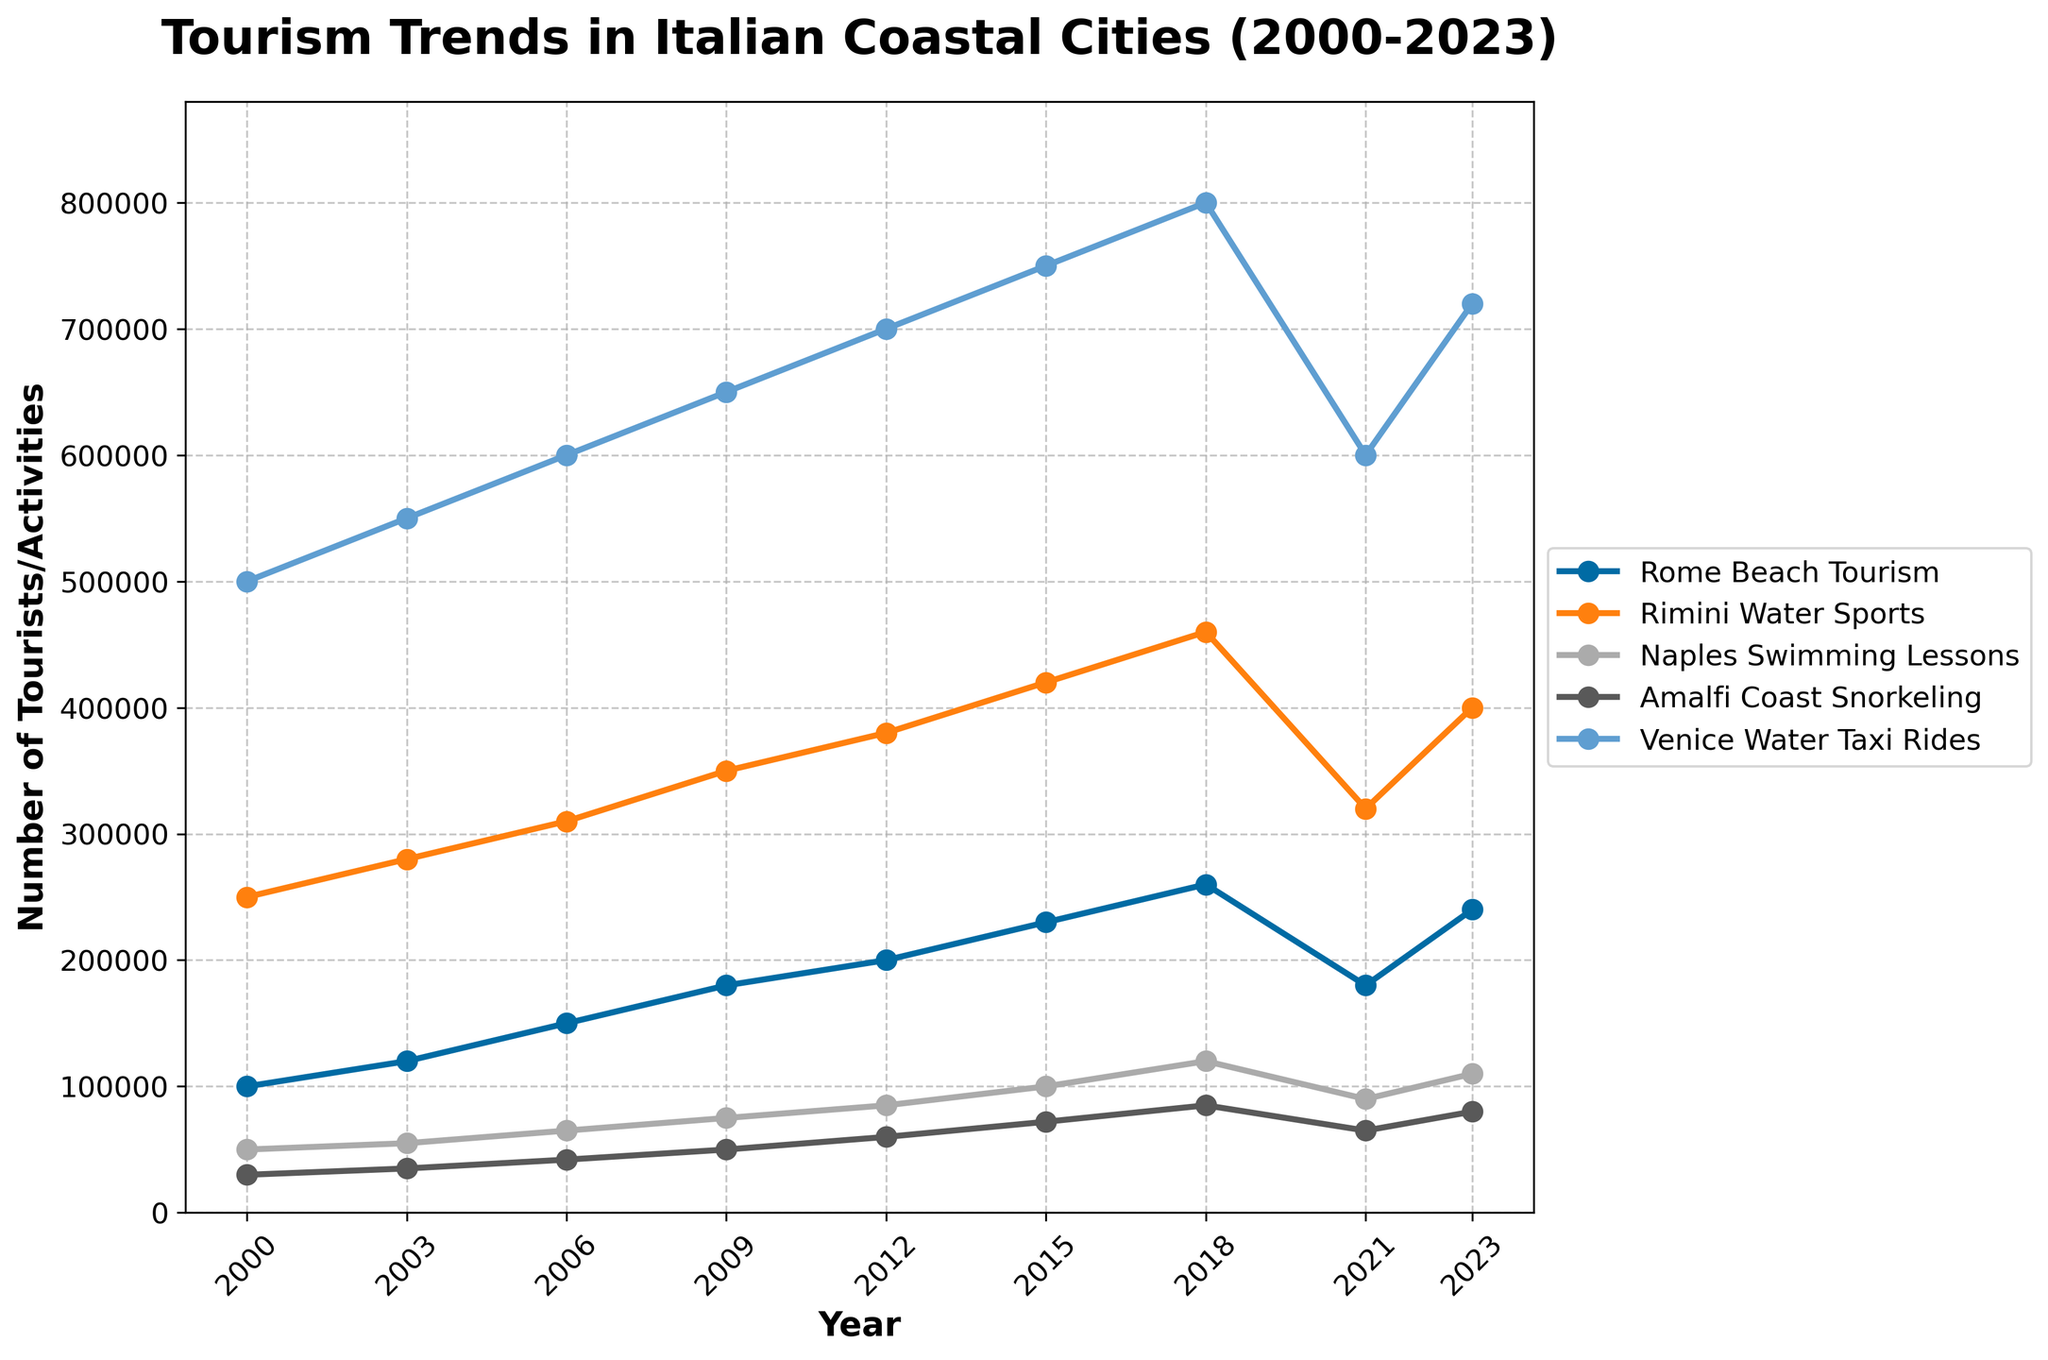How did the number of beach tourists in Rome change from 2021 to 2023? In 2021, the number of beach tourists in Rome was 180,000, and in 2023, it was 240,000. To find the change, subtract the 2021 figure from the 2023 figure: 240,000 - 180,000 = 60,000.
Answer: Increased by 60,000 Which city had the highest number of tourists or activities in 2000, and what was the figure? By looking at the year's data for 2000, Venice had the highest number with 500,000 water taxi rides.
Answer: Venice, 500,000 What's the average number of tourists/activities across all cities in 2023? Add the figures for all cities in 2023 (240,000 + 400,000 + 110,000 + 80,000 + 720,000) and divide by the number of cities (5). The sum is 1,550,000, and the average is 1,550,000 / 5 = 310,000.
Answer: 310,000 Compare the trend of Rimini Water Sports and Naples Swimming Lessons from 2000 to 2023. Which one had a higher overall increase? Calculate the difference between the 2023 and 2000 figures for both: 
Rimini: 400,000 - 250,000 = 150,000 
Naples: 110,000 - 50,000 = 60,000. Rimini had a higher overall increase of 150,000 compared to Naples' 60,000.
Answer: Rimini Water Sports What years did Rome Beach Tourism and Venice Water Taxi Rides both show an increase compared to the previous recorded year? Observe the figures for both Rome and Venice. They both increased from:
2000 to 2003, 2003 to 2006, 2006 to 2009, and 2018 to 2023.
Answer: 2003, 2006, 2009, 2023 In which year did Amalfi Coast Snorkeling see the highest number of participants, and what was the number? The highest number can be found in 2018 with 85,000 participants.
Answer: 2018, 85,000 By how much did Venice Water Taxi Rides fall between 2018 and 2021? The number in 2018 was 800,000, and in 2021 it was 600,000. The decrease is calculated as 800,000 - 600,000 = 200,000.
Answer: Decreased by 200,000 What were the overall trends for Tourism in Rome from 2000 to 2023? Identify if the numbers increased, decreased, or fluctuated. The values generally increased until 2018, dropped in 2021, and then increased again in 2023.
Answer: Generally increasing with a drop in 2021 Which activity had the smallest increase from 2000 to 2023, and what was the increase? Calculate the increase for each activity:
Rome Beach: 240,000 - 100,000 = 140,000
Rimini Water Sports: 400,000 - 250,000 = 150,000
Naples Swimming: 110,000 - 50,000 = 60,000
Amalfi Snorkeling: 80,000 - 30,000 = 50,000
Venice Water Taxi: 720,000 - 500,000 = 220,000.
Amalfi Coast Snorkeling had the smallest increase of 50,000.
Answer: Amalfi Coast Snorkeling, 50,000 